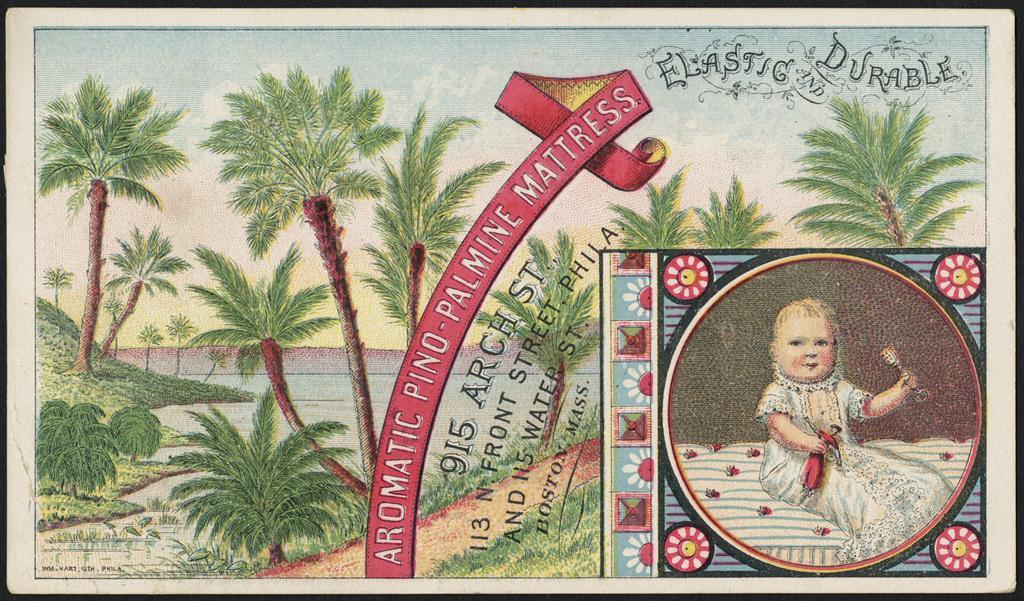Describe this image in one or two sentences. In this image we can see a photo frame included with trees, water, grass, a photo of a baby and we can also see some text written on it. 